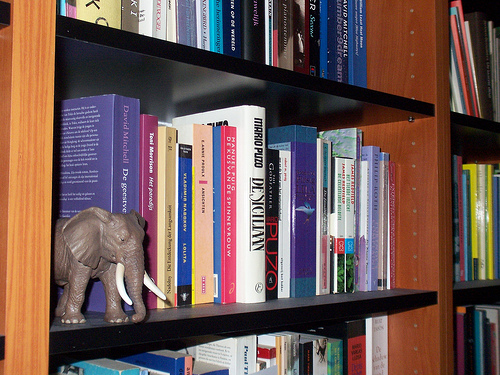<image>
Is there a elephant under the book shelf? No. The elephant is not positioned under the book shelf. The vertical relationship between these objects is different. Where is the books in relation to the shelf? Is it in the shelf? Yes. The books is contained within or inside the shelf, showing a containment relationship. Is there a elephant on the shelf? Yes. Looking at the image, I can see the elephant is positioned on top of the shelf, with the shelf providing support. Is there a toy to the left of the book? Yes. From this viewpoint, the toy is positioned to the left side relative to the book. 